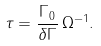<formula> <loc_0><loc_0><loc_500><loc_500>\tau = \frac { \Gamma _ { 0 } } { \delta \Gamma } \, \Omega ^ { - 1 } .</formula> 